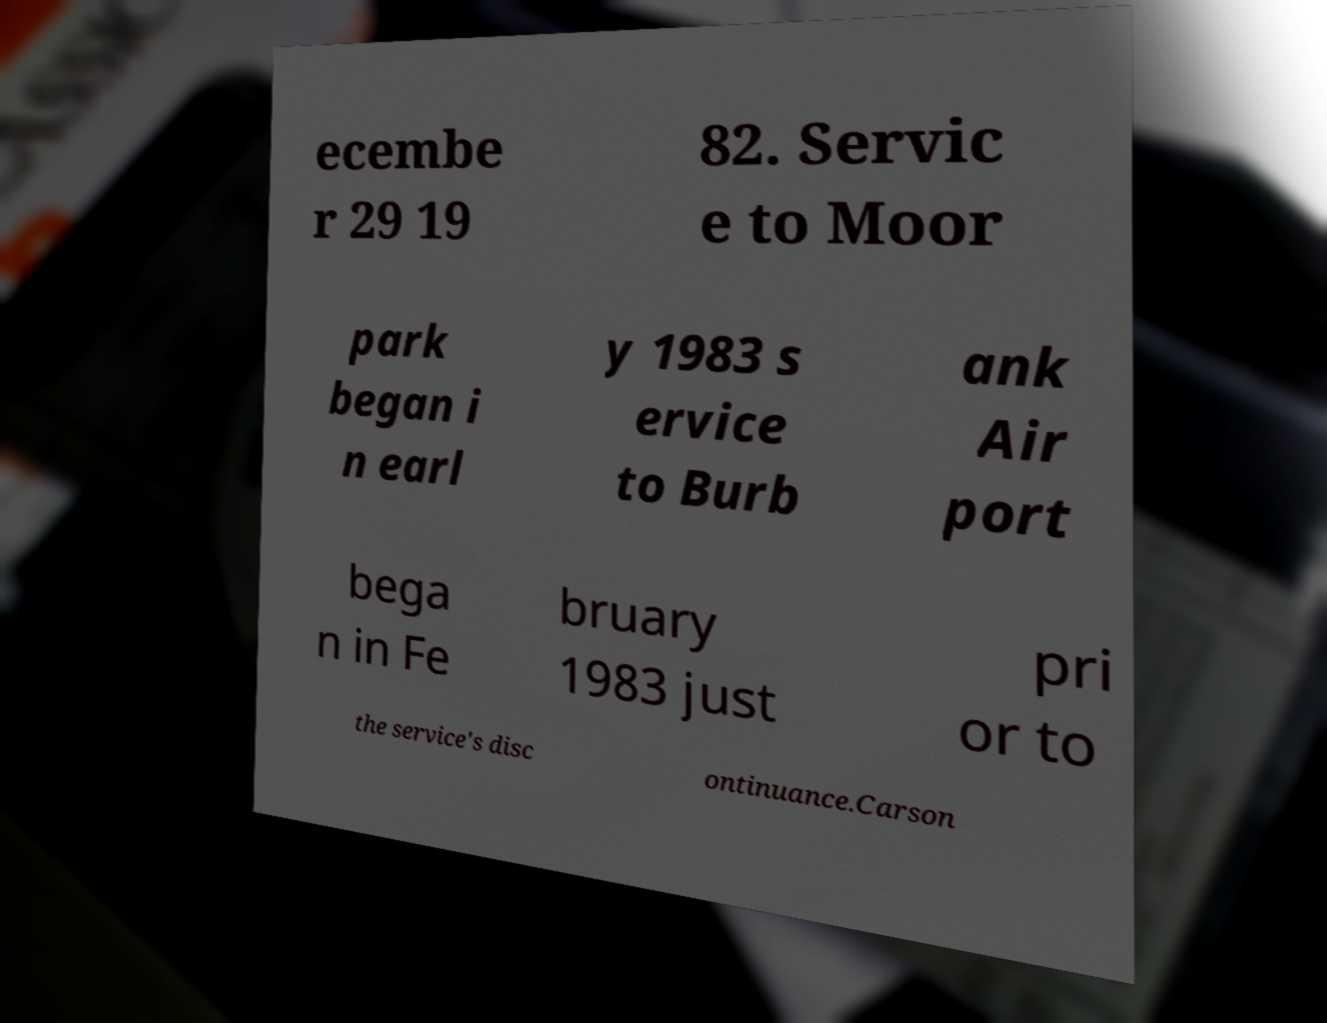Could you assist in decoding the text presented in this image and type it out clearly? ecembe r 29 19 82. Servic e to Moor park began i n earl y 1983 s ervice to Burb ank Air port bega n in Fe bruary 1983 just pri or to the service's disc ontinuance.Carson 